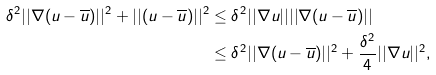Convert formula to latex. <formula><loc_0><loc_0><loc_500><loc_500>\delta ^ { 2 } | | \nabla ( u - \overline { u } ) | | ^ { 2 } + | | ( u - \overline { u } ) | | ^ { 2 } & \leq \delta ^ { 2 } | | \nabla u | | | | \nabla ( u - \overline { u } ) | | \\ & \leq \delta ^ { 2 } | | \nabla ( u - \overline { u } ) | | ^ { 2 } + \frac { \delta ^ { 2 } } { 4 } | | \nabla u | | ^ { 2 } ,</formula> 